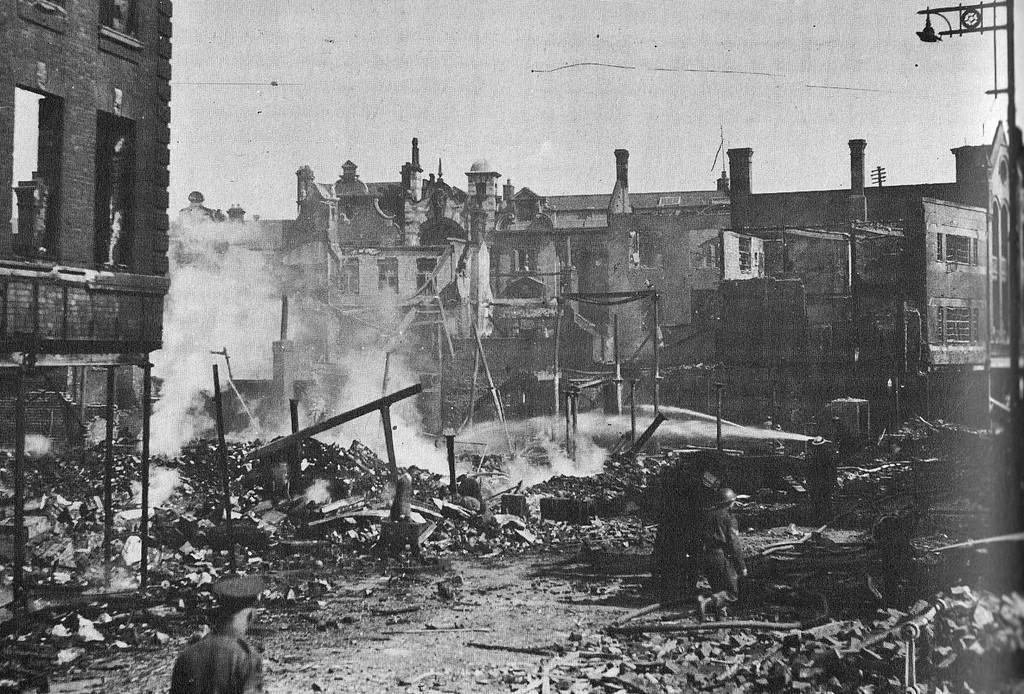What type of structures can be seen in the image? There are buildings in the image. Are there any people present in the image? Yes, there is a person in the image. What part of the natural environment is visible in the image? The sky is visible in the image. What type of slope can be seen in the image? There is no slope present in the image; it features buildings, a person, and the sky. 